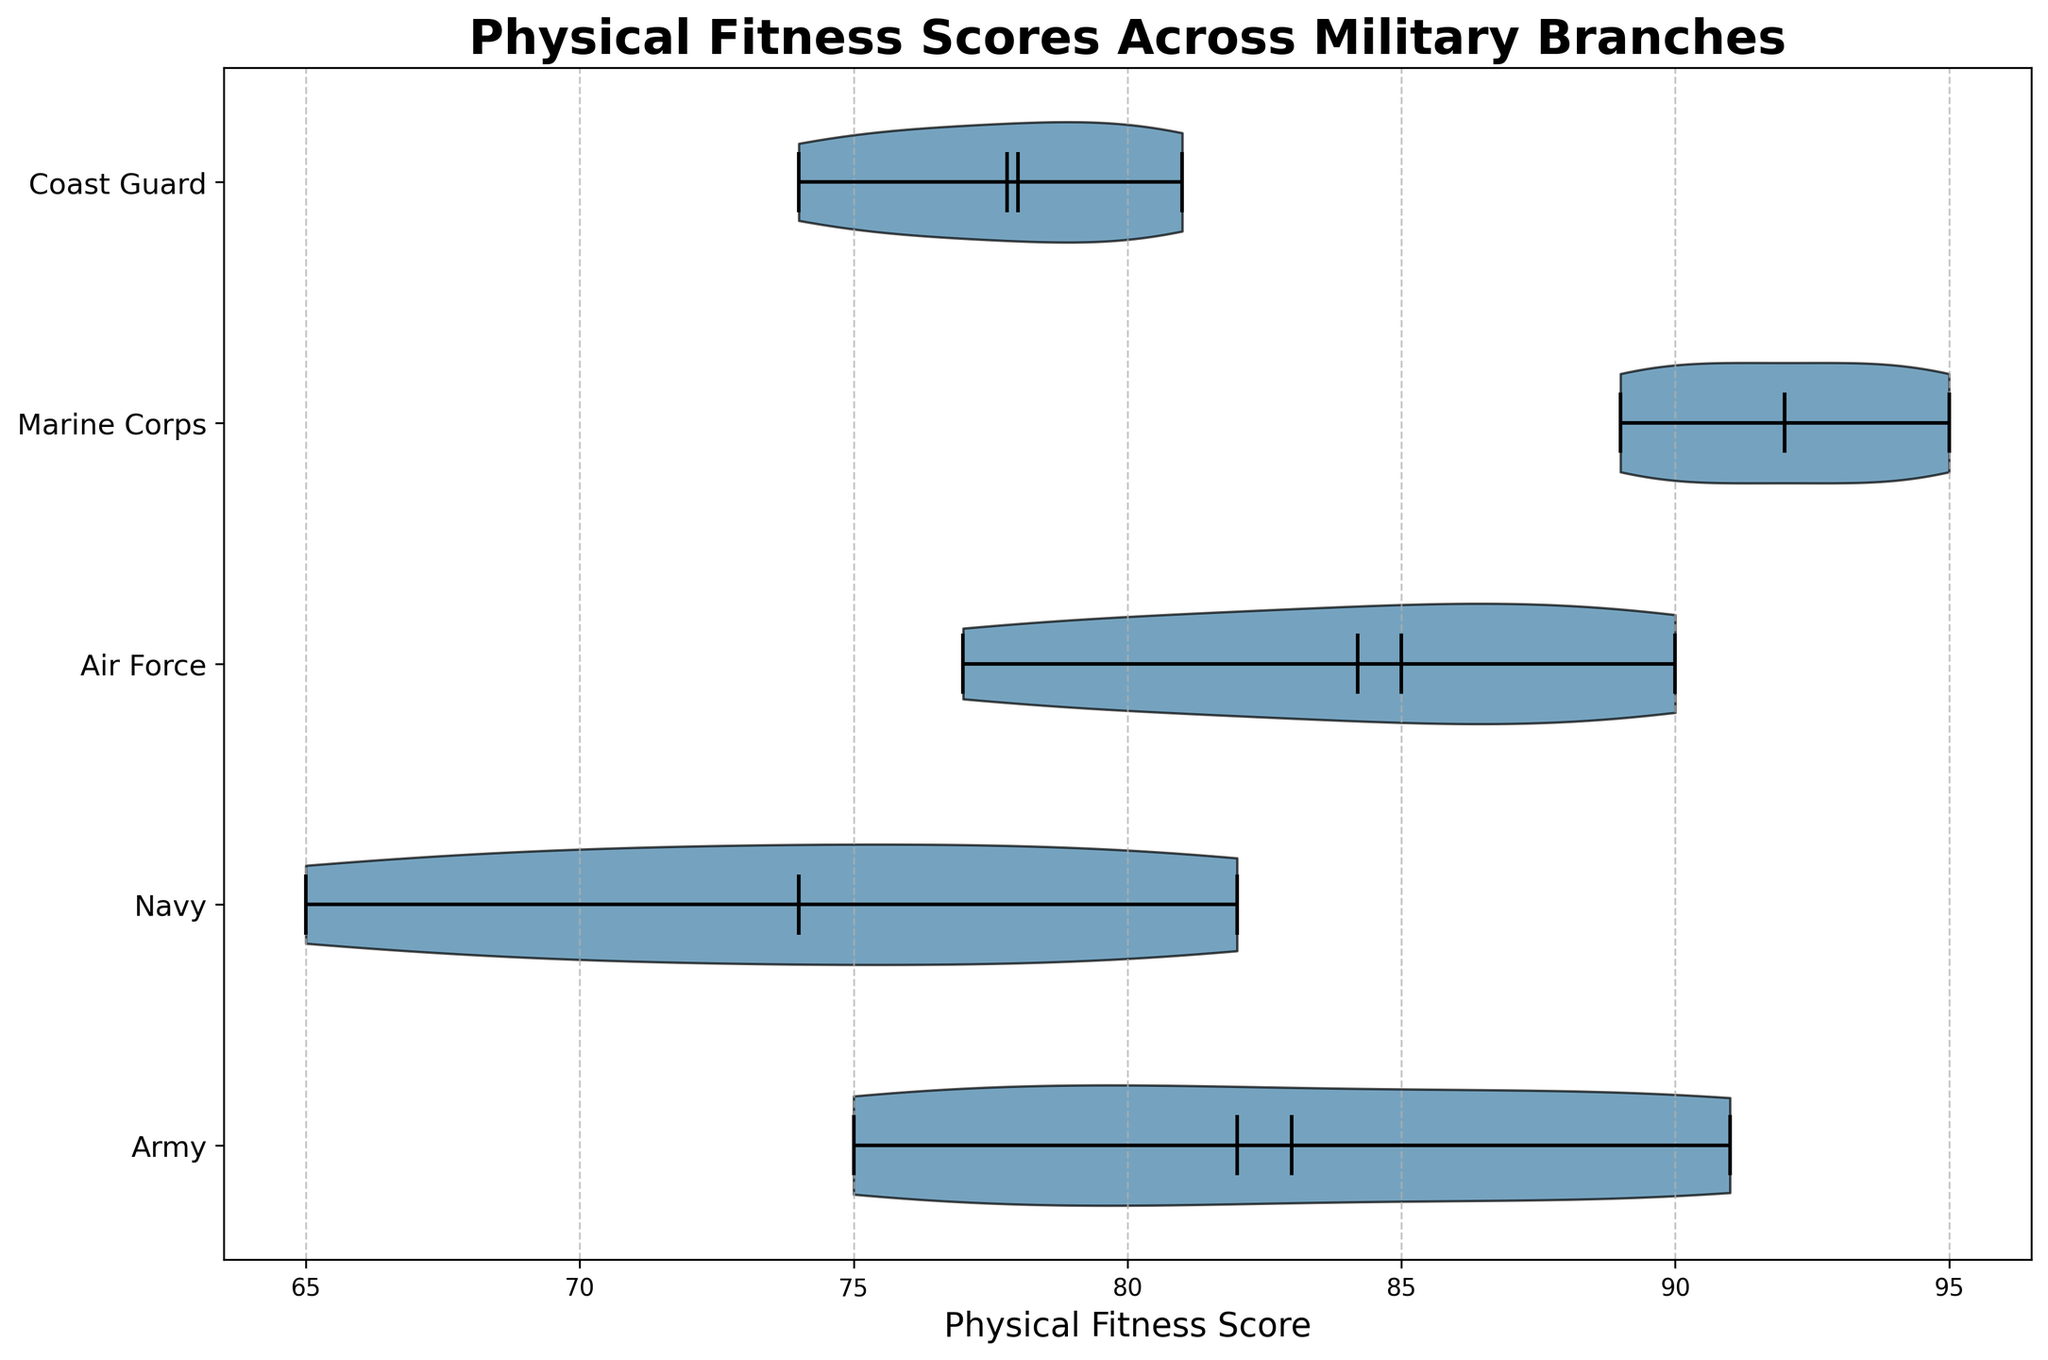What's the title of the figure? The title is displayed at the top of the figure. It reads "Physical Fitness Scores Across Military Branches".
Answer: Physical Fitness Scores Across Military Branches Which branch has the highest median physical fitness score? By observing the horizontal line inside the "violin" shapes, which represents the median, we can see that the Marine Corps has the highest median line.
Answer: Marine Corps What are the general physical fitness score ranges for the Army and Navy? Looking at the spans of the violins for Army and Navy, the Army’s scores extend roughly from 75 to 91 while the Navy’s scores range from about 65 to 82.
Answer: Army: 75-91, Navy: 65-82 Which branch has the most spread-out scores? The spread of each branch’s scores is represented by the width of the violins. The Army and Navy appear to have the widest violins, indicating the most spread-out scores.
Answer: Army and Navy Does the Air Force have a higher mean score than the Coast Guard? The small triangles on the violins indicate the mean scores. By observing these triangles, it is clear that the Air Force's mean (around 84) is higher than the Coast Guard’s mean (around 77).
Answer: Yes What is the interquartile range of the Marine Corps? The interquartile range is shown by the width of the densest part of the violin. For the Marine Corps, this range appears to be between approximately 90 and 94.
Answer: 90-94 Which branch has the least variability in their physical fitness scores? The narrowest violin indicates the least variability in scores. The Marine Corps has the violin with the narrowest spread, suggesting the least variability.
Answer: Marine Corps How does the median score of the Coast Guard compare to the mean score of the Army? Comparing the horizontal line (median) inside the Coast Guard violin with the small triangle (mean) inside the Army violin shows that both are about the same, around 78.
Answer: Approximately the same Which branch's physical fitness scores are skewed towards higher values? The skew in the violin plot is indicated by the shape of the violin. The Air Force and Marine Corps violins appear slightly skewed towards higher values.
Answer: Air Force and Marine Corps What's the range of the interquartile values for the Air Force and how does it compare to the Navy? The interquartile range can be seen in the dense middle part of the violins. For the Air Force, it ranges approximately from 81 to 88, while for the Navy, it is from around 70 to 79. The Air Force has a higher interquartile range compared to the Navy.
Answer: Air Force: 81-88, Navy: 70-79 